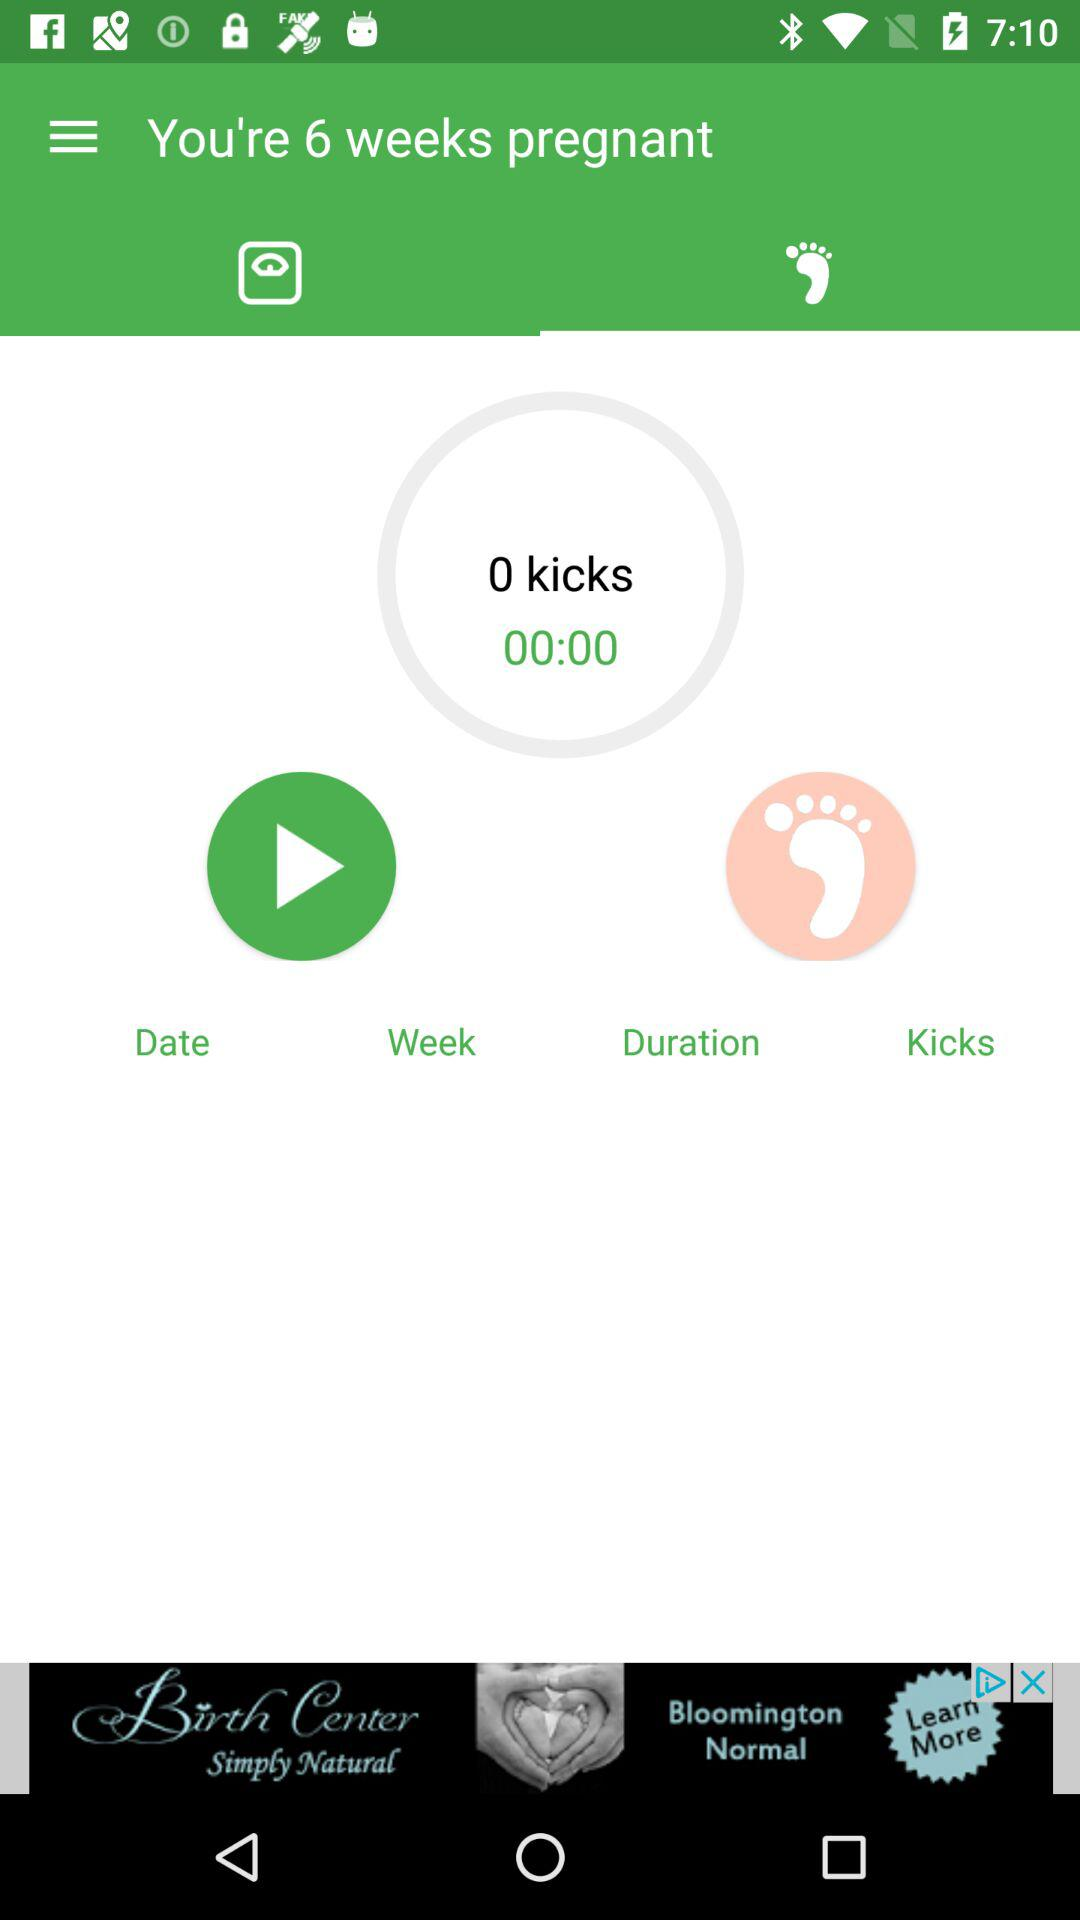How many more weeks pregnant am I than the number of kicks I've recorded?
Answer the question using a single word or phrase. 6 